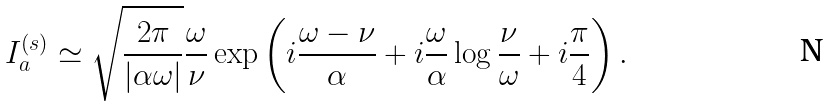Convert formula to latex. <formula><loc_0><loc_0><loc_500><loc_500>I _ { a } ^ { ( s ) } \simeq \sqrt { \frac { 2 \pi } { | \alpha \omega | } } \frac { \omega } { \nu } \exp \left ( i \frac { \omega - \nu } { \alpha } + i \frac { \omega } { \alpha } \log \frac { \nu } { \omega } + i \frac { \pi } { 4 } \right ) .</formula> 